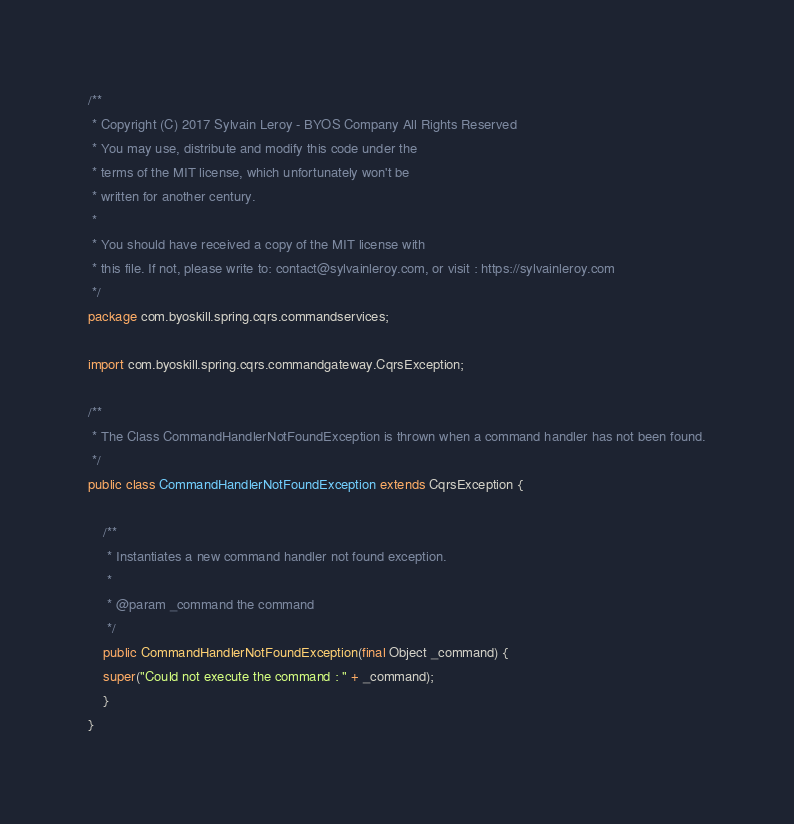<code> <loc_0><loc_0><loc_500><loc_500><_Java_>/**
 * Copyright (C) 2017 Sylvain Leroy - BYOS Company All Rights Reserved
 * You may use, distribute and modify this code under the
 * terms of the MIT license, which unfortunately won't be
 * written for another century.
 *
 * You should have received a copy of the MIT license with
 * this file. If not, please write to: contact@sylvainleroy.com, or visit : https://sylvainleroy.com
 */
package com.byoskill.spring.cqrs.commandservices;

import com.byoskill.spring.cqrs.commandgateway.CqrsException;

/**
 * The Class CommandHandlerNotFoundException is thrown when a command handler has not been found.
 */
public class CommandHandlerNotFoundException extends CqrsException {

    /**
     * Instantiates a new command handler not found exception.
     *
     * @param _command the command
     */
    public CommandHandlerNotFoundException(final Object _command) {
	super("Could not execute the command : " + _command);
    }
}
</code> 